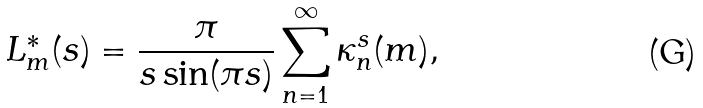<formula> <loc_0><loc_0><loc_500><loc_500>L _ { m } ^ { * } ( s ) = \frac { \pi } { s \sin ( \pi s ) } \sum _ { n = 1 } ^ { \infty } \kappa _ { n } ^ { s } ( m ) ,</formula> 